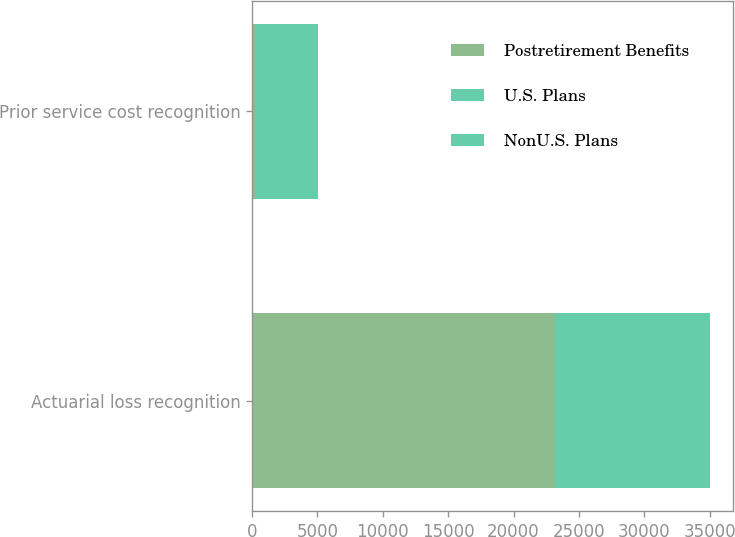Convert chart. <chart><loc_0><loc_0><loc_500><loc_500><stacked_bar_chart><ecel><fcel>Actuarial loss recognition<fcel>Prior service cost recognition<nl><fcel>Postretirement Benefits<fcel>23171<fcel>308<nl><fcel>U.S. Plans<fcel>9765<fcel>15<nl><fcel>NonU.S. Plans<fcel>2060<fcel>4712<nl></chart> 